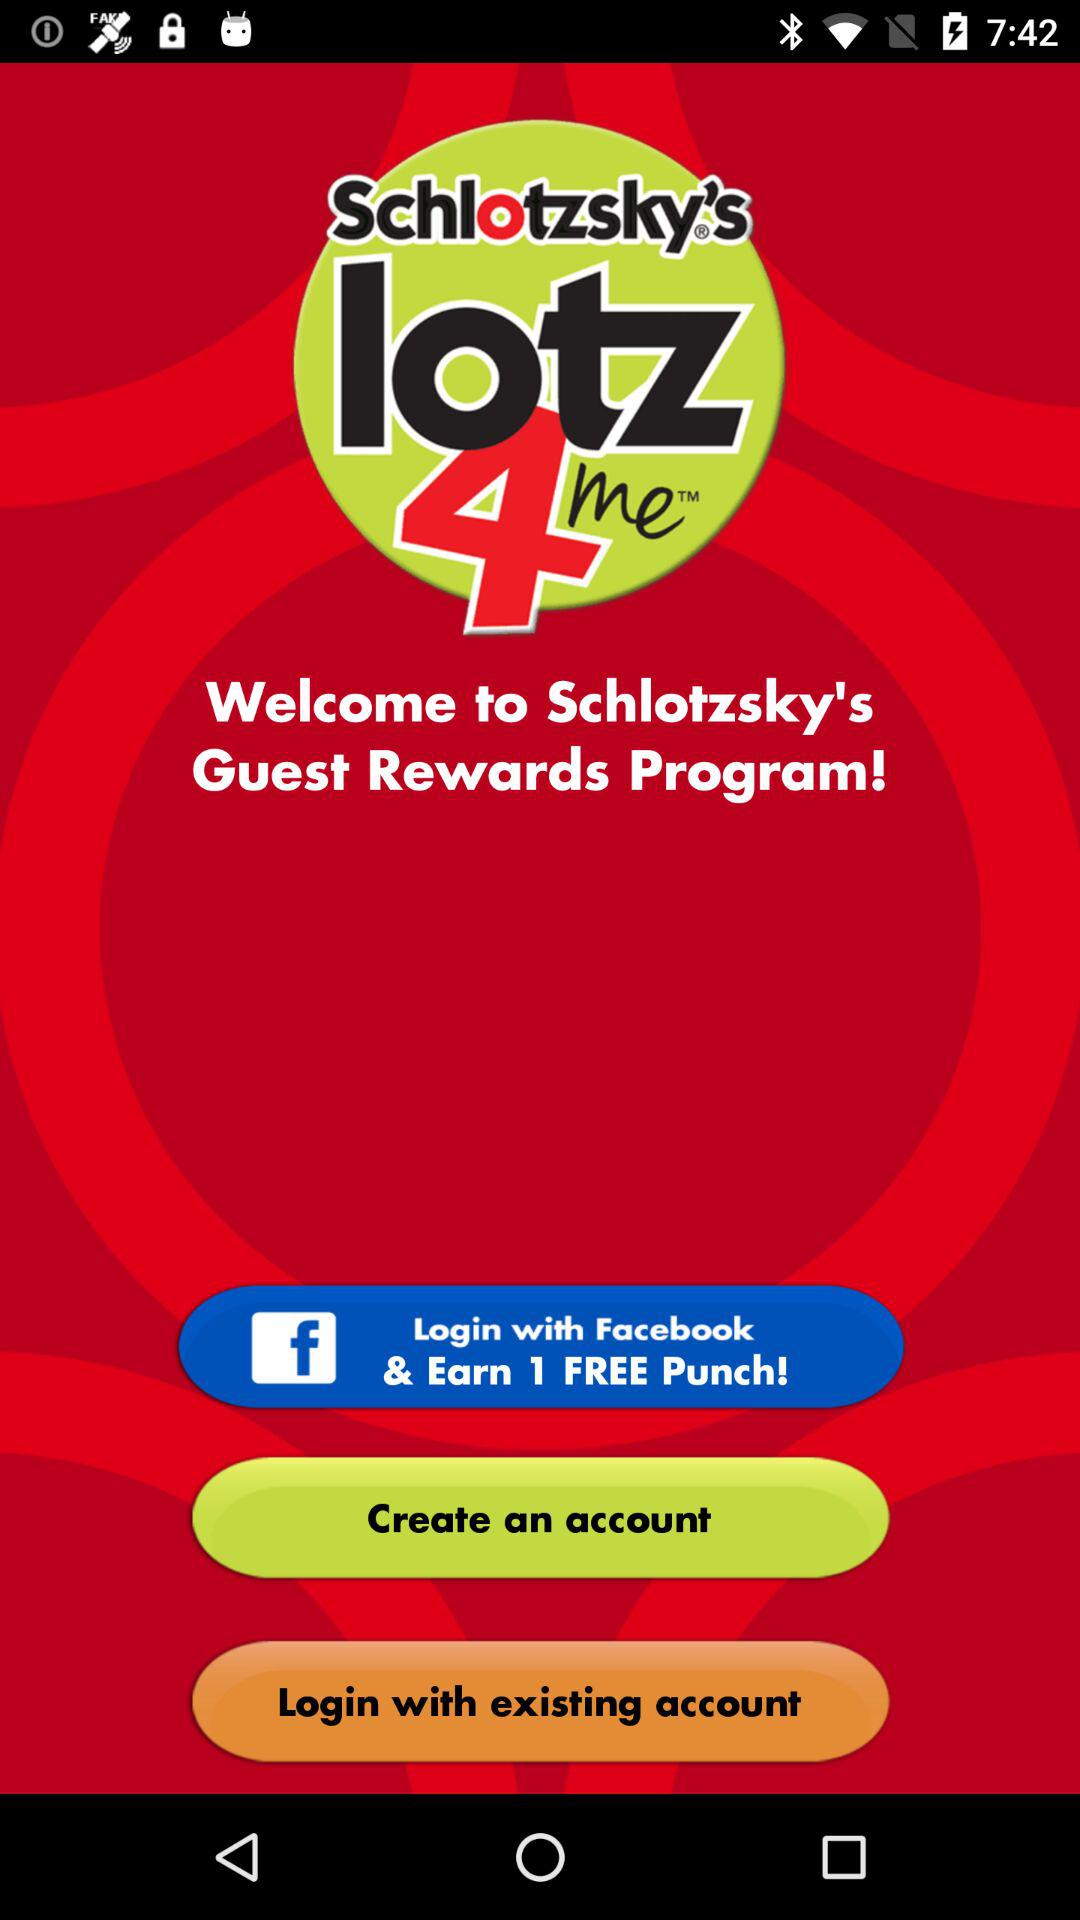What would you earn if you logged in with "Facebook"? If you logged in with "Facebook", you would earn 1 free punch. 